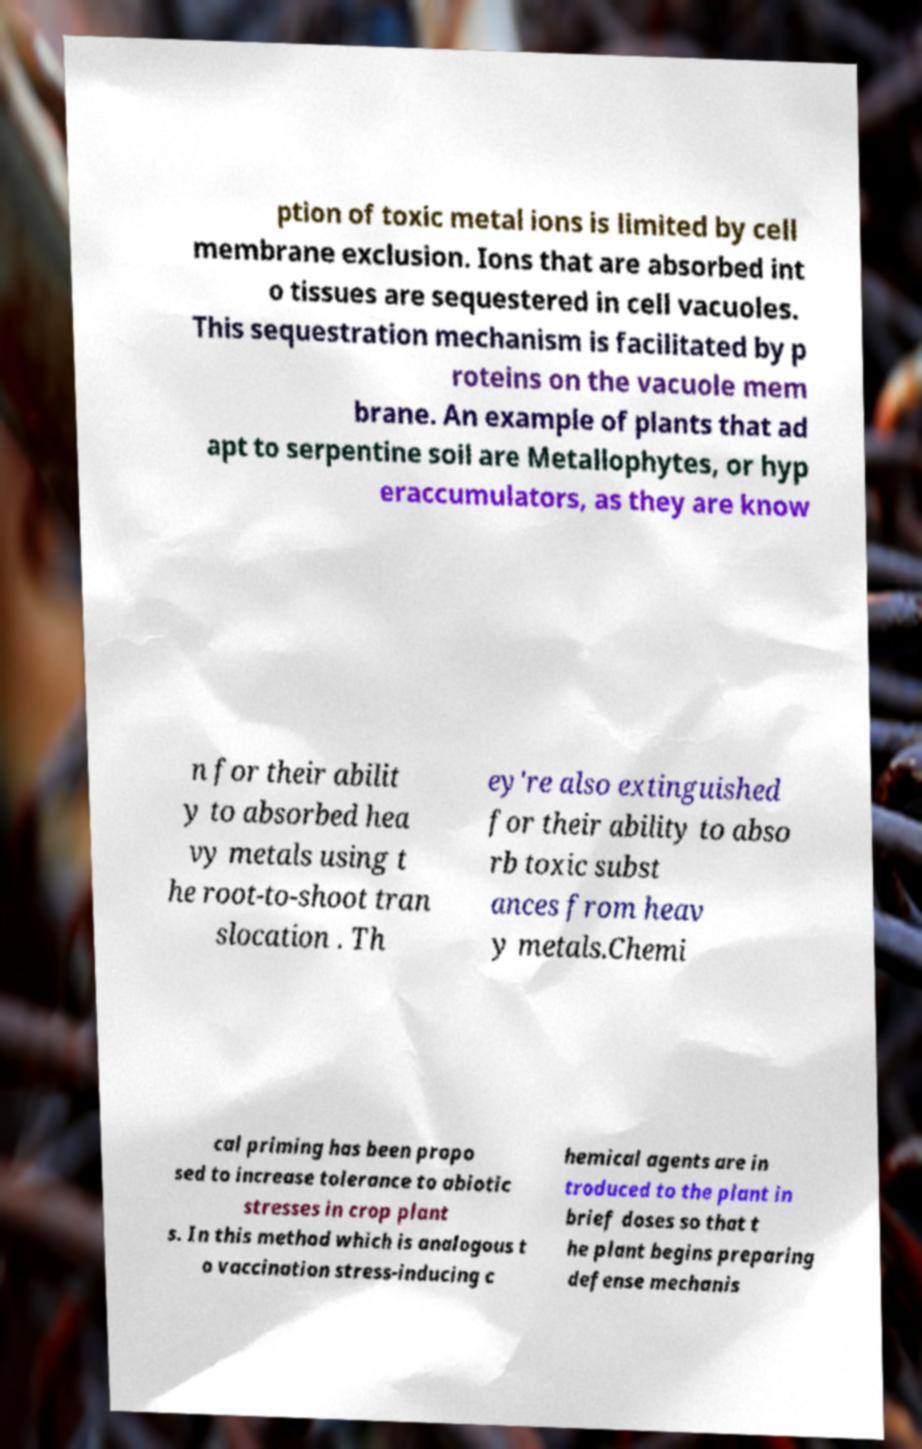Please read and relay the text visible in this image. What does it say? ption of toxic metal ions is limited by cell membrane exclusion. Ions that are absorbed int o tissues are sequestered in cell vacuoles. This sequestration mechanism is facilitated by p roteins on the vacuole mem brane. An example of plants that ad apt to serpentine soil are Metallophytes, or hyp eraccumulators, as they are know n for their abilit y to absorbed hea vy metals using t he root-to-shoot tran slocation . Th ey're also extinguished for their ability to abso rb toxic subst ances from heav y metals.Chemi cal priming has been propo sed to increase tolerance to abiotic stresses in crop plant s. In this method which is analogous t o vaccination stress-inducing c hemical agents are in troduced to the plant in brief doses so that t he plant begins preparing defense mechanis 